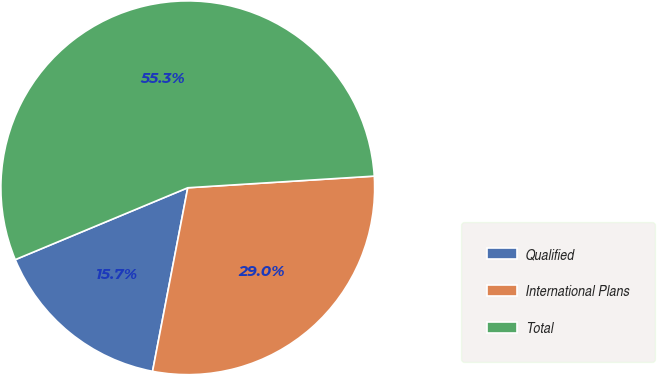<chart> <loc_0><loc_0><loc_500><loc_500><pie_chart><fcel>Qualified<fcel>International Plans<fcel>Total<nl><fcel>15.7%<fcel>29.01%<fcel>55.29%<nl></chart> 